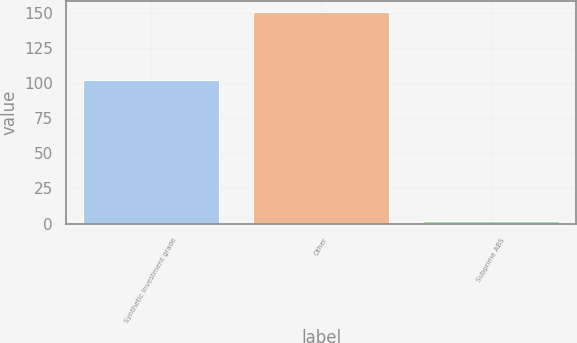<chart> <loc_0><loc_0><loc_500><loc_500><bar_chart><fcel>Synthetic investment grade<fcel>Other<fcel>Subprime ABS<nl><fcel>102<fcel>151<fcel>2<nl></chart> 